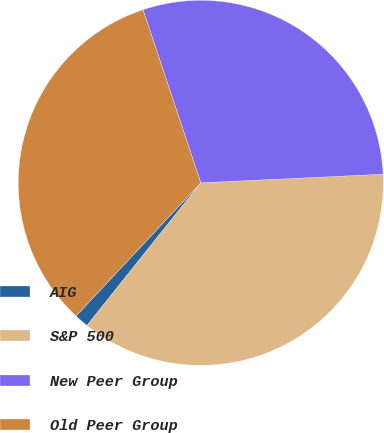<chart> <loc_0><loc_0><loc_500><loc_500><pie_chart><fcel>AIG<fcel>S&P 500<fcel>New Peer Group<fcel>Old Peer Group<nl><fcel>1.27%<fcel>36.46%<fcel>29.37%<fcel>32.89%<nl></chart> 